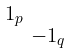<formula> <loc_0><loc_0><loc_500><loc_500>\begin{smallmatrix} 1 _ { p } & \\ & - 1 _ { q } \end{smallmatrix}</formula> 